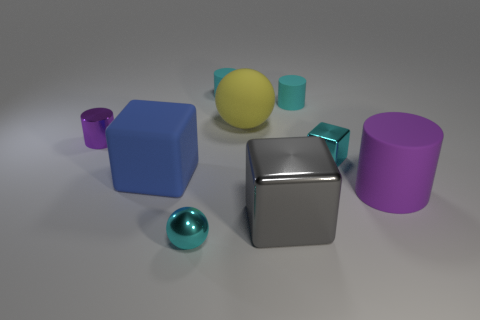Subtract all purple metallic cylinders. How many cylinders are left? 3 Add 1 yellow rubber things. How many objects exist? 10 Subtract all brown cubes. How many purple cylinders are left? 2 Subtract all purple cylinders. How many cylinders are left? 2 Subtract 3 blocks. How many blocks are left? 0 Subtract all cylinders. How many objects are left? 5 Subtract all red cylinders. Subtract all brown blocks. How many cylinders are left? 4 Subtract all small purple rubber cylinders. Subtract all small matte cylinders. How many objects are left? 7 Add 6 small cyan shiny cubes. How many small cyan shiny cubes are left? 7 Add 2 rubber balls. How many rubber balls exist? 3 